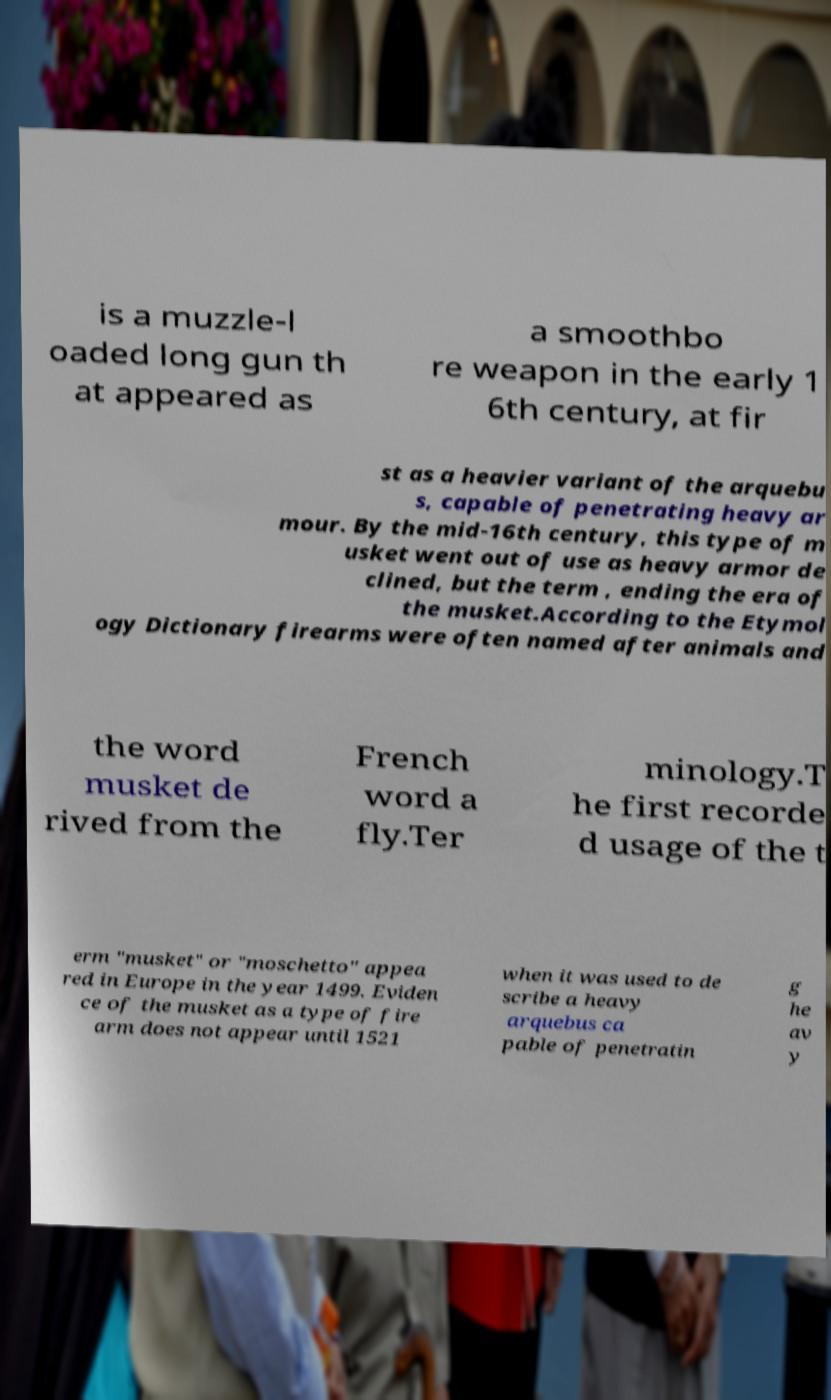Please identify and transcribe the text found in this image. is a muzzle-l oaded long gun th at appeared as a smoothbo re weapon in the early 1 6th century, at fir st as a heavier variant of the arquebu s, capable of penetrating heavy ar mour. By the mid-16th century, this type of m usket went out of use as heavy armor de clined, but the term , ending the era of the musket.According to the Etymol ogy Dictionary firearms were often named after animals and the word musket de rived from the French word a fly.Ter minology.T he first recorde d usage of the t erm "musket" or "moschetto" appea red in Europe in the year 1499. Eviden ce of the musket as a type of fire arm does not appear until 1521 when it was used to de scribe a heavy arquebus ca pable of penetratin g he av y 